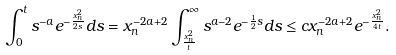Convert formula to latex. <formula><loc_0><loc_0><loc_500><loc_500>\int _ { 0 } ^ { t } s ^ { - a } e ^ { - \frac { x _ { n } ^ { 2 } } { 2 s } } d s & = x _ { n } ^ { - 2 a + 2 } \int ^ { \infty } _ { \frac { x _ { n } ^ { 2 } } t } s ^ { a - 2 } e ^ { - \frac { 1 } { 2 } s } d s \leq c x _ { n } ^ { - 2 a + 2 } e ^ { - \frac { x _ { n } ^ { 2 } } { 4 t } } .</formula> 